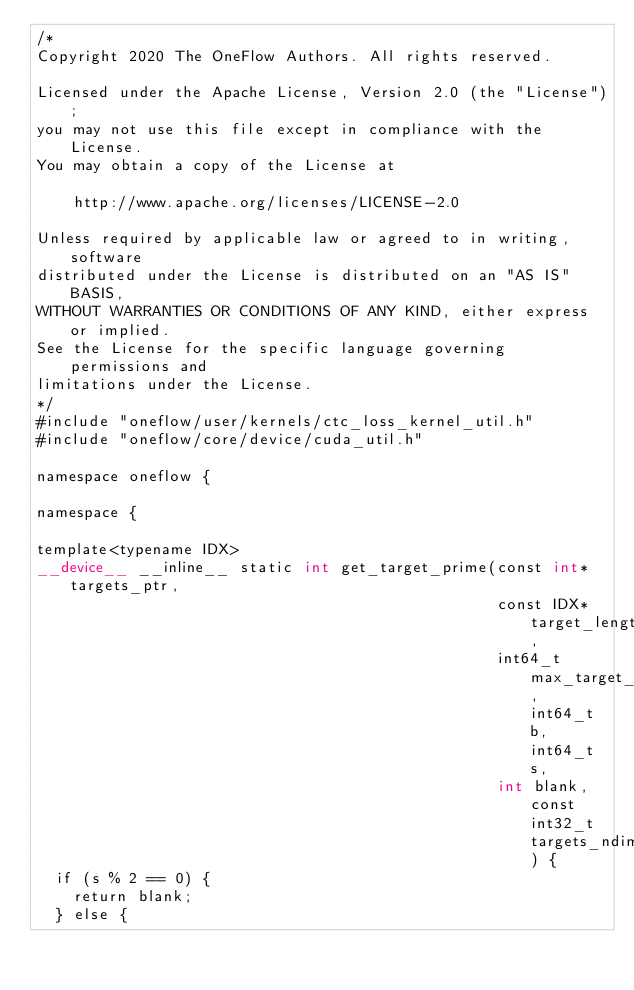<code> <loc_0><loc_0><loc_500><loc_500><_Cuda_>/*
Copyright 2020 The OneFlow Authors. All rights reserved.

Licensed under the Apache License, Version 2.0 (the "License");
you may not use this file except in compliance with the License.
You may obtain a copy of the License at

    http://www.apache.org/licenses/LICENSE-2.0

Unless required by applicable law or agreed to in writing, software
distributed under the License is distributed on an "AS IS" BASIS,
WITHOUT WARRANTIES OR CONDITIONS OF ANY KIND, either express or implied.
See the License for the specific language governing permissions and
limitations under the License.
*/
#include "oneflow/user/kernels/ctc_loss_kernel_util.h"
#include "oneflow/core/device/cuda_util.h"

namespace oneflow {

namespace {

template<typename IDX>
__device__ __inline__ static int get_target_prime(const int* targets_ptr,
                                                  const IDX* target_lengths_ptr,
                                                  int64_t max_target_length, int64_t b, int64_t s,
                                                  int blank, const int32_t targets_ndim) {
  if (s % 2 == 0) {
    return blank;
  } else {</code> 